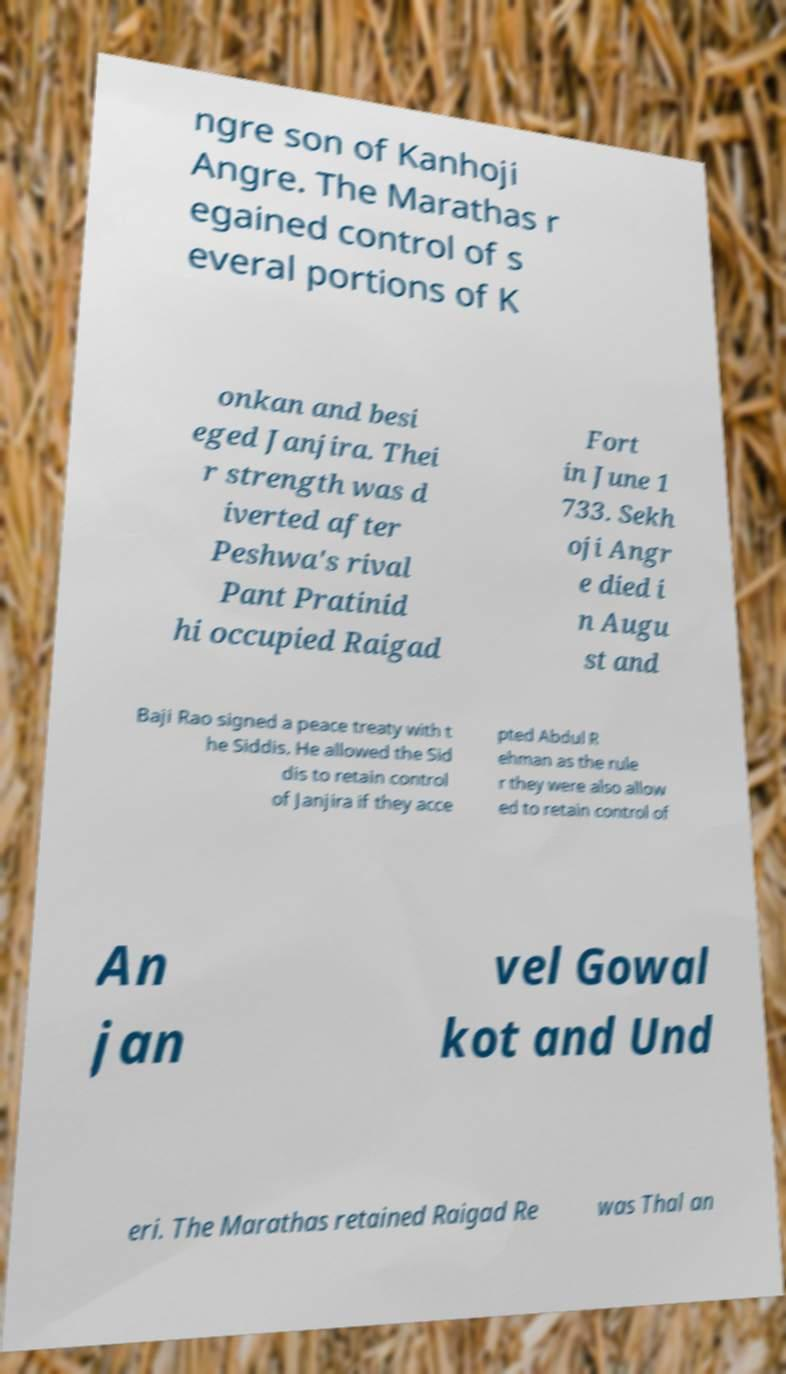Could you assist in decoding the text presented in this image and type it out clearly? ngre son of Kanhoji Angre. The Marathas r egained control of s everal portions of K onkan and besi eged Janjira. Thei r strength was d iverted after Peshwa's rival Pant Pratinid hi occupied Raigad Fort in June 1 733. Sekh oji Angr e died i n Augu st and Baji Rao signed a peace treaty with t he Siddis. He allowed the Sid dis to retain control of Janjira if they acce pted Abdul R ehman as the rule r they were also allow ed to retain control of An jan vel Gowal kot and Und eri. The Marathas retained Raigad Re was Thal an 